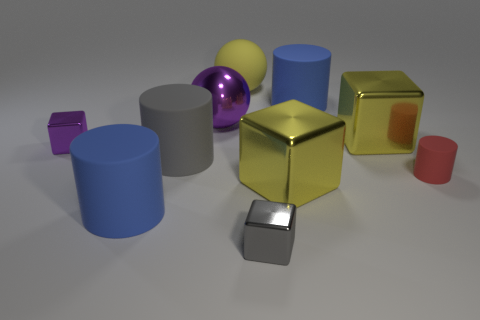Is the number of red cylinders that are behind the yellow sphere less than the number of small red cylinders in front of the small purple cube? Indeed, the number of red cylinders positioned behind the yellow sphere is fewer compared to the number of smaller red cylinders situated in front of the small purple cube. Observing the spatial arrangement within the image allows us to determine the specific count and their relative positions, ensuring a precise comparison. 